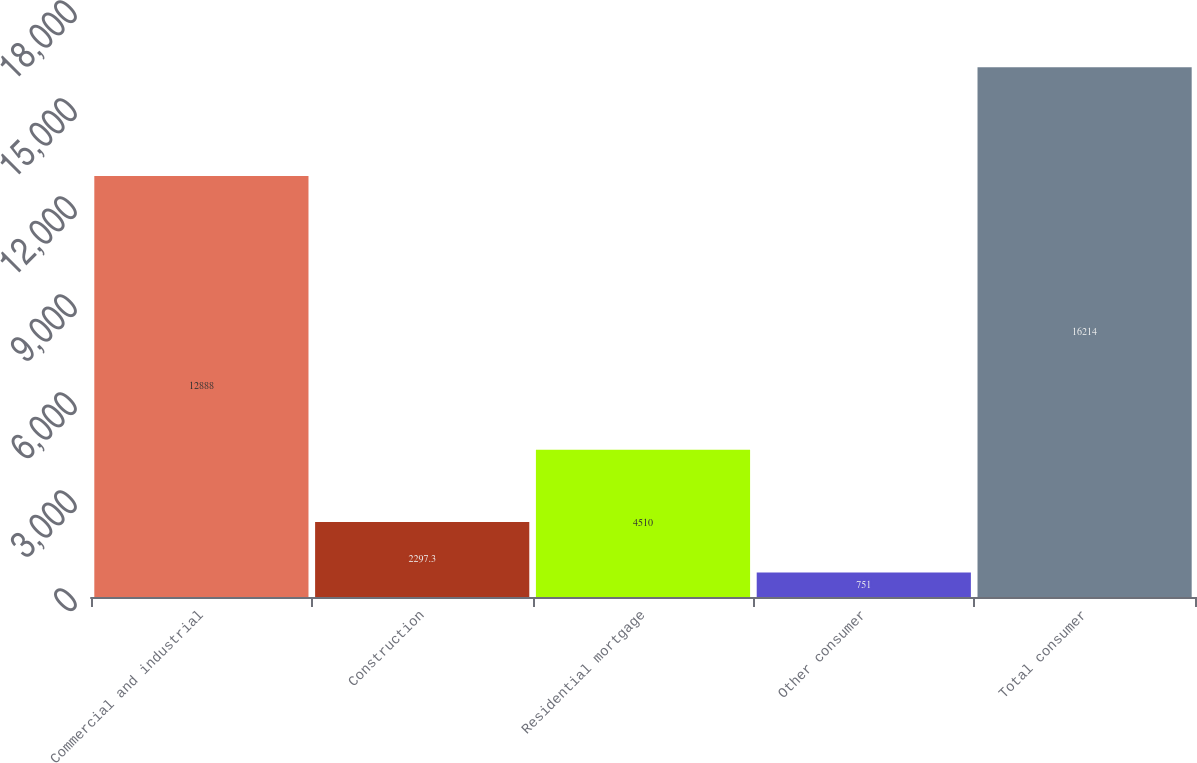<chart> <loc_0><loc_0><loc_500><loc_500><bar_chart><fcel>Commercial and industrial<fcel>Construction<fcel>Residential mortgage<fcel>Other consumer<fcel>Total consumer<nl><fcel>12888<fcel>2297.3<fcel>4510<fcel>751<fcel>16214<nl></chart> 